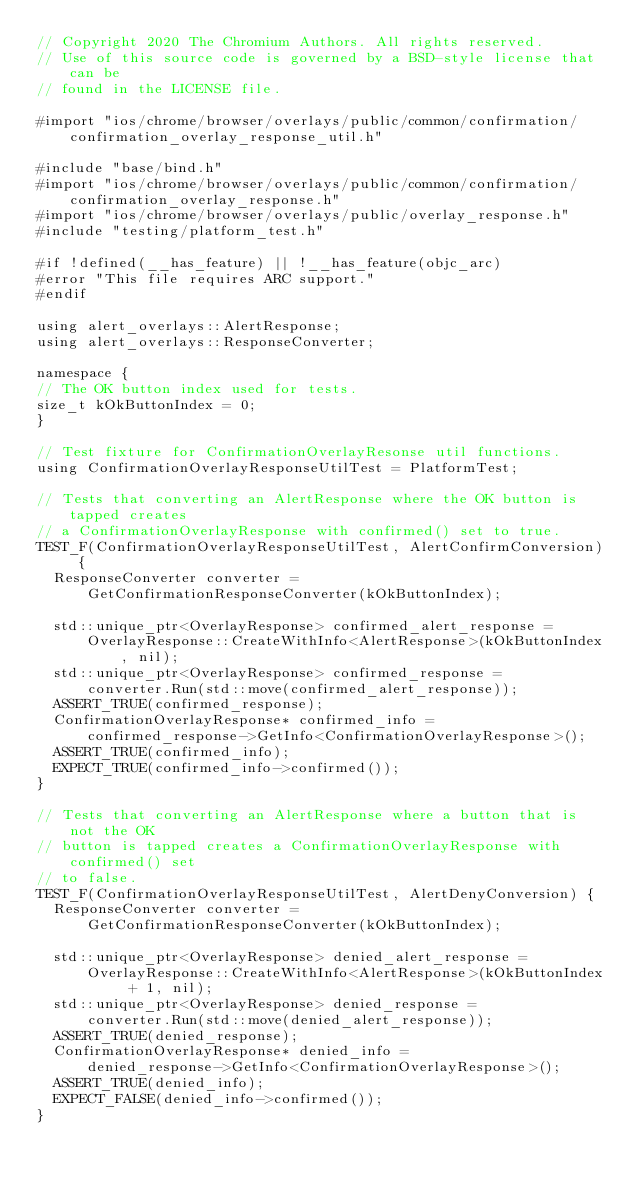<code> <loc_0><loc_0><loc_500><loc_500><_ObjectiveC_>// Copyright 2020 The Chromium Authors. All rights reserved.
// Use of this source code is governed by a BSD-style license that can be
// found in the LICENSE file.

#import "ios/chrome/browser/overlays/public/common/confirmation/confirmation_overlay_response_util.h"

#include "base/bind.h"
#import "ios/chrome/browser/overlays/public/common/confirmation/confirmation_overlay_response.h"
#import "ios/chrome/browser/overlays/public/overlay_response.h"
#include "testing/platform_test.h"

#if !defined(__has_feature) || !__has_feature(objc_arc)
#error "This file requires ARC support."
#endif

using alert_overlays::AlertResponse;
using alert_overlays::ResponseConverter;

namespace {
// The OK button index used for tests.
size_t kOkButtonIndex = 0;
}

// Test fixture for ConfirmationOverlayResonse util functions.
using ConfirmationOverlayResponseUtilTest = PlatformTest;

// Tests that converting an AlertResponse where the OK button is tapped creates
// a ConfirmationOverlayResponse with confirmed() set to true.
TEST_F(ConfirmationOverlayResponseUtilTest, AlertConfirmConversion) {
  ResponseConverter converter =
      GetConfirmationResponseConverter(kOkButtonIndex);

  std::unique_ptr<OverlayResponse> confirmed_alert_response =
      OverlayResponse::CreateWithInfo<AlertResponse>(kOkButtonIndex, nil);
  std::unique_ptr<OverlayResponse> confirmed_response =
      converter.Run(std::move(confirmed_alert_response));
  ASSERT_TRUE(confirmed_response);
  ConfirmationOverlayResponse* confirmed_info =
      confirmed_response->GetInfo<ConfirmationOverlayResponse>();
  ASSERT_TRUE(confirmed_info);
  EXPECT_TRUE(confirmed_info->confirmed());
}

// Tests that converting an AlertResponse where a button that is not the OK
// button is tapped creates a ConfirmationOverlayResponse with confirmed() set
// to false.
TEST_F(ConfirmationOverlayResponseUtilTest, AlertDenyConversion) {
  ResponseConverter converter =
      GetConfirmationResponseConverter(kOkButtonIndex);

  std::unique_ptr<OverlayResponse> denied_alert_response =
      OverlayResponse::CreateWithInfo<AlertResponse>(kOkButtonIndex + 1, nil);
  std::unique_ptr<OverlayResponse> denied_response =
      converter.Run(std::move(denied_alert_response));
  ASSERT_TRUE(denied_response);
  ConfirmationOverlayResponse* denied_info =
      denied_response->GetInfo<ConfirmationOverlayResponse>();
  ASSERT_TRUE(denied_info);
  EXPECT_FALSE(denied_info->confirmed());
}
</code> 